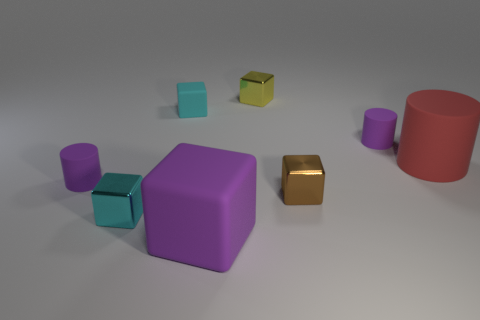There is a small purple thing on the right side of the tiny yellow cube; does it have the same shape as the small yellow object?
Offer a terse response. No. What is the shape of the big red rubber object?
Give a very brief answer. Cylinder. What number of small purple cylinders have the same material as the large red cylinder?
Give a very brief answer. 2. There is a large cylinder; is its color the same as the cylinder that is in front of the large red rubber thing?
Offer a terse response. No. What number of tiny metallic spheres are there?
Your response must be concise. 0. Are there any big rubber cylinders of the same color as the tiny rubber cube?
Provide a succinct answer. No. There is a shiny block that is behind the small purple matte thing that is in front of the small cylinder to the right of the purple rubber cube; what is its color?
Your answer should be very brief. Yellow. Does the yellow block have the same material as the tiny purple thing on the left side of the purple block?
Provide a short and direct response. No. What material is the red cylinder?
Your response must be concise. Rubber. What is the material of the object that is the same color as the tiny matte block?
Provide a succinct answer. Metal. 